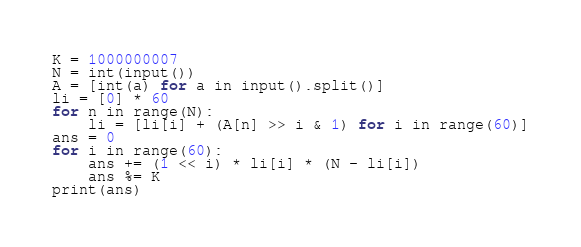Convert code to text. <code><loc_0><loc_0><loc_500><loc_500><_Python_>K = 1000000007
N = int(input())
A = [int(a) for a in input().split()]
li = [0] * 60
for n in range(N):
    li = [li[i] + (A[n] >> i & 1) for i in range(60)]
ans = 0
for i in range(60):
    ans += (1 << i) * li[i] * (N - li[i])
    ans %= K
print(ans)</code> 